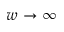Convert formula to latex. <formula><loc_0><loc_0><loc_500><loc_500>w \rightarrow \infty</formula> 